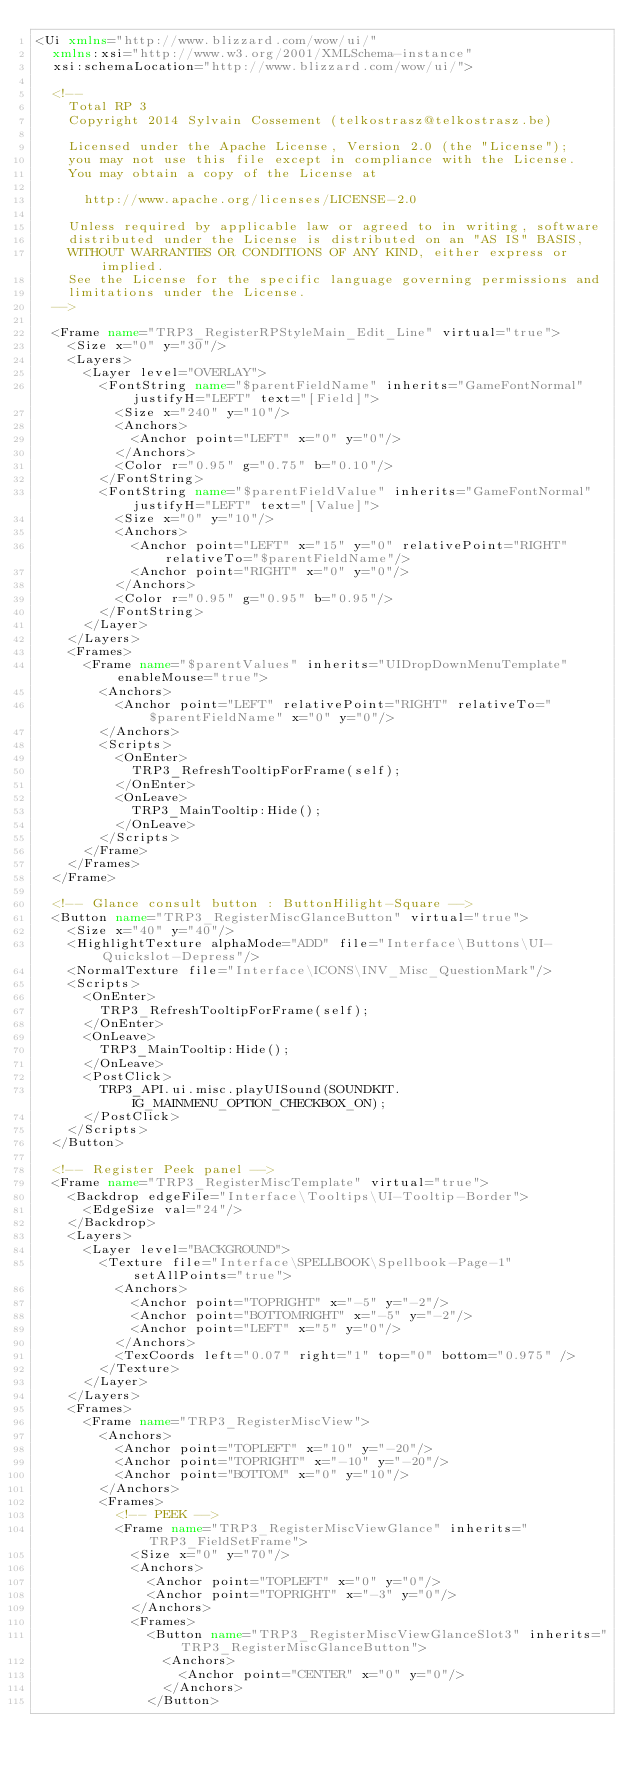Convert code to text. <code><loc_0><loc_0><loc_500><loc_500><_XML_><Ui xmlns="http://www.blizzard.com/wow/ui/"
	xmlns:xsi="http://www.w3.org/2001/XMLSchema-instance"
	xsi:schemaLocation="http://www.blizzard.com/wow/ui/">

	<!--
		Total RP 3
		Copyright 2014 Sylvain Cossement (telkostrasz@telkostrasz.be)

		Licensed under the Apache License, Version 2.0 (the "License");
		you may not use this file except in compliance with the License.
		You may obtain a copy of the License at

			http://www.apache.org/licenses/LICENSE-2.0

		Unless required by applicable law or agreed to in writing, software
		distributed under the License is distributed on an "AS IS" BASIS,
		WITHOUT WARRANTIES OR CONDITIONS OF ANY KIND, either express or implied.
		See the License for the specific language governing permissions and
		limitations under the License.
	-->

	<Frame name="TRP3_RegisterRPStyleMain_Edit_Line" virtual="true">
		<Size x="0" y="30"/>
		<Layers>
			<Layer level="OVERLAY">
				<FontString name="$parentFieldName" inherits="GameFontNormal" justifyH="LEFT" text="[Field]">
					<Size x="240" y="10"/>
					<Anchors>
						<Anchor point="LEFT" x="0" y="0"/>
					</Anchors>
					<Color r="0.95" g="0.75" b="0.10"/>
				</FontString>
				<FontString name="$parentFieldValue" inherits="GameFontNormal" justifyH="LEFT" text="[Value]">
					<Size x="0" y="10"/>
					<Anchors>
						<Anchor point="LEFT" x="15" y="0" relativePoint="RIGHT" relativeTo="$parentFieldName"/>
						<Anchor point="RIGHT" x="0" y="0"/>
					</Anchors>
					<Color r="0.95" g="0.95" b="0.95"/>
				</FontString>
			</Layer>
		</Layers>
		<Frames>
			<Frame name="$parentValues" inherits="UIDropDownMenuTemplate" enableMouse="true">
				<Anchors>
					<Anchor point="LEFT" relativePoint="RIGHT" relativeTo="$parentFieldName" x="0" y="0"/>
				</Anchors>
				<Scripts>
					<OnEnter>
						TRP3_RefreshTooltipForFrame(self);
					</OnEnter>
					<OnLeave>
						TRP3_MainTooltip:Hide();
					</OnLeave>
				</Scripts>
			</Frame>
		</Frames>
	</Frame>

	<!-- Glance consult button : ButtonHilight-Square -->
	<Button name="TRP3_RegisterMiscGlanceButton" virtual="true">
		<Size x="40" y="40"/>
		<HighlightTexture alphaMode="ADD" file="Interface\Buttons\UI-Quickslot-Depress"/>
		<NormalTexture file="Interface\ICONS\INV_Misc_QuestionMark"/>
		<Scripts>
			<OnEnter>
				TRP3_RefreshTooltipForFrame(self);
			</OnEnter>
			<OnLeave>
				TRP3_MainTooltip:Hide();
			</OnLeave>
			<PostClick>
				TRP3_API.ui.misc.playUISound(SOUNDKIT.IG_MAINMENU_OPTION_CHECKBOX_ON);
			</PostClick>
		</Scripts>
	</Button>

	<!-- Register Peek panel -->
	<Frame name="TRP3_RegisterMiscTemplate" virtual="true">
		<Backdrop edgeFile="Interface\Tooltips\UI-Tooltip-Border">
			<EdgeSize val="24"/>
		</Backdrop>
		<Layers>
			<Layer level="BACKGROUND">
				<Texture file="Interface\SPELLBOOK\Spellbook-Page-1" setAllPoints="true">
					<Anchors>
						<Anchor point="TOPRIGHT" x="-5" y="-2"/>
						<Anchor point="BOTTOMRIGHT" x="-5" y="-2"/>
						<Anchor point="LEFT" x="5" y="0"/>
					</Anchors>
					<TexCoords left="0.07" right="1" top="0" bottom="0.975" />
				</Texture>
			</Layer>
		</Layers>
		<Frames>
			<Frame name="TRP3_RegisterMiscView">
				<Anchors>
					<Anchor point="TOPLEFT" x="10" y="-20"/>
					<Anchor point="TOPRIGHT" x="-10" y="-20"/>
					<Anchor point="BOTTOM" x="0" y="10"/>
				</Anchors>
				<Frames>
					<!-- PEEK -->
					<Frame name="TRP3_RegisterMiscViewGlance" inherits="TRP3_FieldSetFrame">
						<Size x="0" y="70"/>
						<Anchors>
							<Anchor point="TOPLEFT" x="0" y="0"/>
							<Anchor point="TOPRIGHT" x="-3" y="0"/>
						</Anchors>
						<Frames>
							<Button name="TRP3_RegisterMiscViewGlanceSlot3" inherits="TRP3_RegisterMiscGlanceButton">
								<Anchors>
									<Anchor point="CENTER" x="0" y="0"/>
								</Anchors>
							</Button></code> 